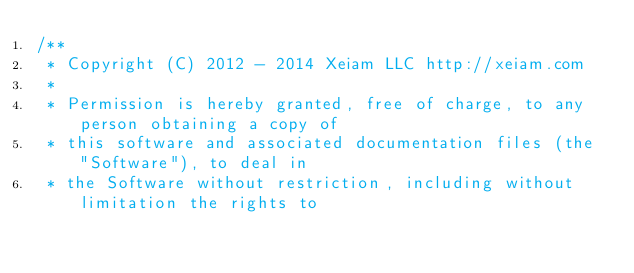<code> <loc_0><loc_0><loc_500><loc_500><_Java_>/**
 * Copyright (C) 2012 - 2014 Xeiam LLC http://xeiam.com
 *
 * Permission is hereby granted, free of charge, to any person obtaining a copy of
 * this software and associated documentation files (the "Software"), to deal in
 * the Software without restriction, including without limitation the rights to</code> 